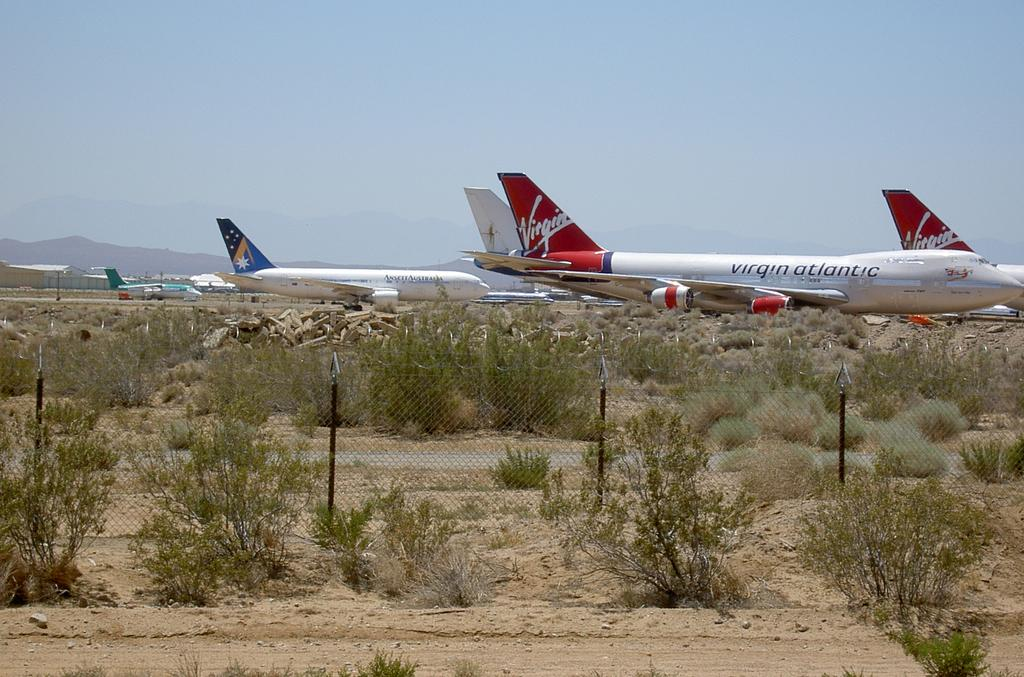<image>
Summarize the visual content of the image. A fleet of red and white Virgin Atlantic airplanes parked on a runway in the desert. 